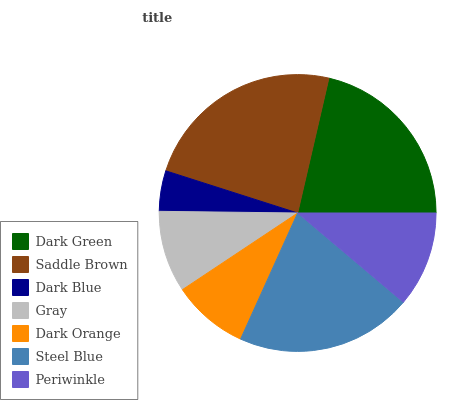Is Dark Blue the minimum?
Answer yes or no. Yes. Is Saddle Brown the maximum?
Answer yes or no. Yes. Is Saddle Brown the minimum?
Answer yes or no. No. Is Dark Blue the maximum?
Answer yes or no. No. Is Saddle Brown greater than Dark Blue?
Answer yes or no. Yes. Is Dark Blue less than Saddle Brown?
Answer yes or no. Yes. Is Dark Blue greater than Saddle Brown?
Answer yes or no. No. Is Saddle Brown less than Dark Blue?
Answer yes or no. No. Is Periwinkle the high median?
Answer yes or no. Yes. Is Periwinkle the low median?
Answer yes or no. Yes. Is Dark Orange the high median?
Answer yes or no. No. Is Dark Blue the low median?
Answer yes or no. No. 